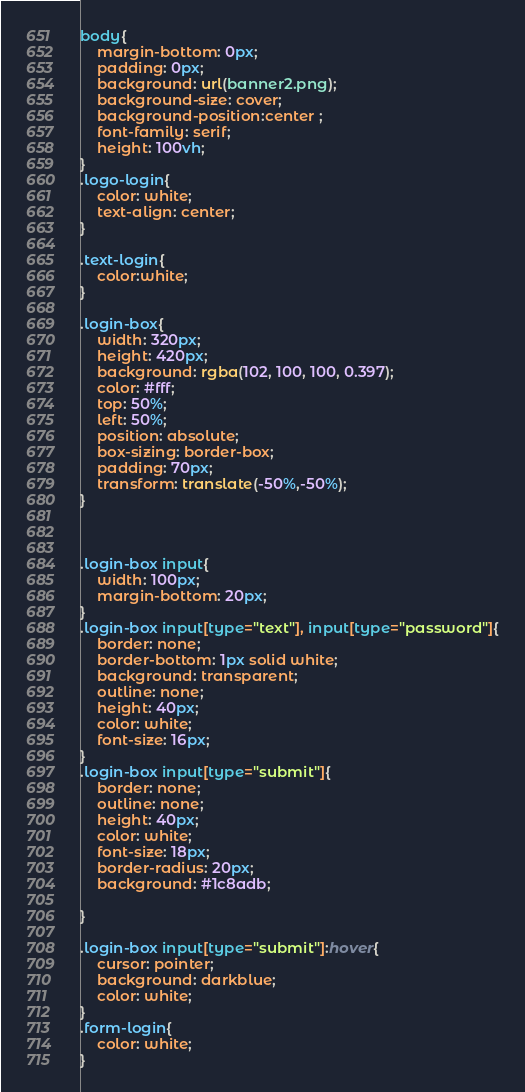<code> <loc_0><loc_0><loc_500><loc_500><_CSS_>body{
    margin-bottom: 0px;
    padding: 0px;
    background: url(banner2.png);
    background-size: cover;
    background-position:center ;
    font-family: serif;
    height: 100vh;
}
.logo-login{
    color: white;
    text-align: center;
}

.text-login{
    color:white;
}

.login-box{
    width: 320px;
    height: 420px;
    background: rgba(102, 100, 100, 0.397);
    color: #fff;
    top: 50%;
    left: 50%;
    position: absolute;
    box-sizing: border-box;
    padding: 70px;
    transform: translate(-50%,-50%);
}



.login-box input{
    width: 100px;
    margin-bottom: 20px;
}
.login-box input[type="text"], input[type="password"]{
    border: none;
    border-bottom: 1px solid white;
    background: transparent;
    outline: none;
    height: 40px;
    color: white;
    font-size: 16px;
}
.login-box input[type="submit"]{
    border: none;
    outline: none;
    height: 40px;
    color: white;
    font-size: 18px;
    border-radius: 20px;
    background: #1c8adb;

}

.login-box input[type="submit"]:hover{
    cursor: pointer;
    background: darkblue;
    color: white;
}
.form-login{
    color: white;
}</code> 